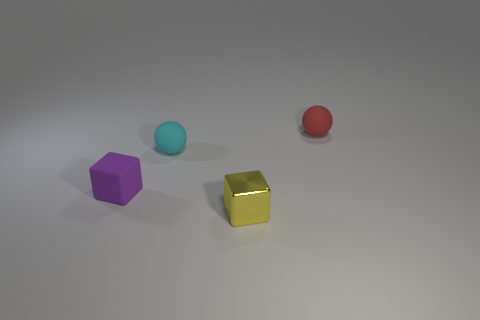The tiny ball that is left of the shiny block that is in front of the small purple matte object is made of what material?
Keep it short and to the point. Rubber. There is a thing that is in front of the small red thing and to the right of the cyan rubber object; what color is it?
Offer a very short reply. Yellow. Do the red sphere and the small cyan sphere have the same material?
Give a very brief answer. Yes. How many big objects are cyan matte objects or matte balls?
Offer a very short reply. 0. Is there any other thing that has the same shape as the small yellow metallic thing?
Provide a short and direct response. Yes. What color is the block that is the same material as the red thing?
Provide a short and direct response. Purple. There is a small thing that is in front of the tiny purple matte cube; what color is it?
Ensure brevity in your answer.  Yellow. Are there fewer small cyan objects right of the tiny yellow thing than small yellow metal cubes that are behind the tiny rubber block?
Your response must be concise. No. There is a small yellow thing; what number of tiny objects are behind it?
Offer a terse response. 3. Are there any purple blocks made of the same material as the cyan object?
Offer a terse response. Yes. 